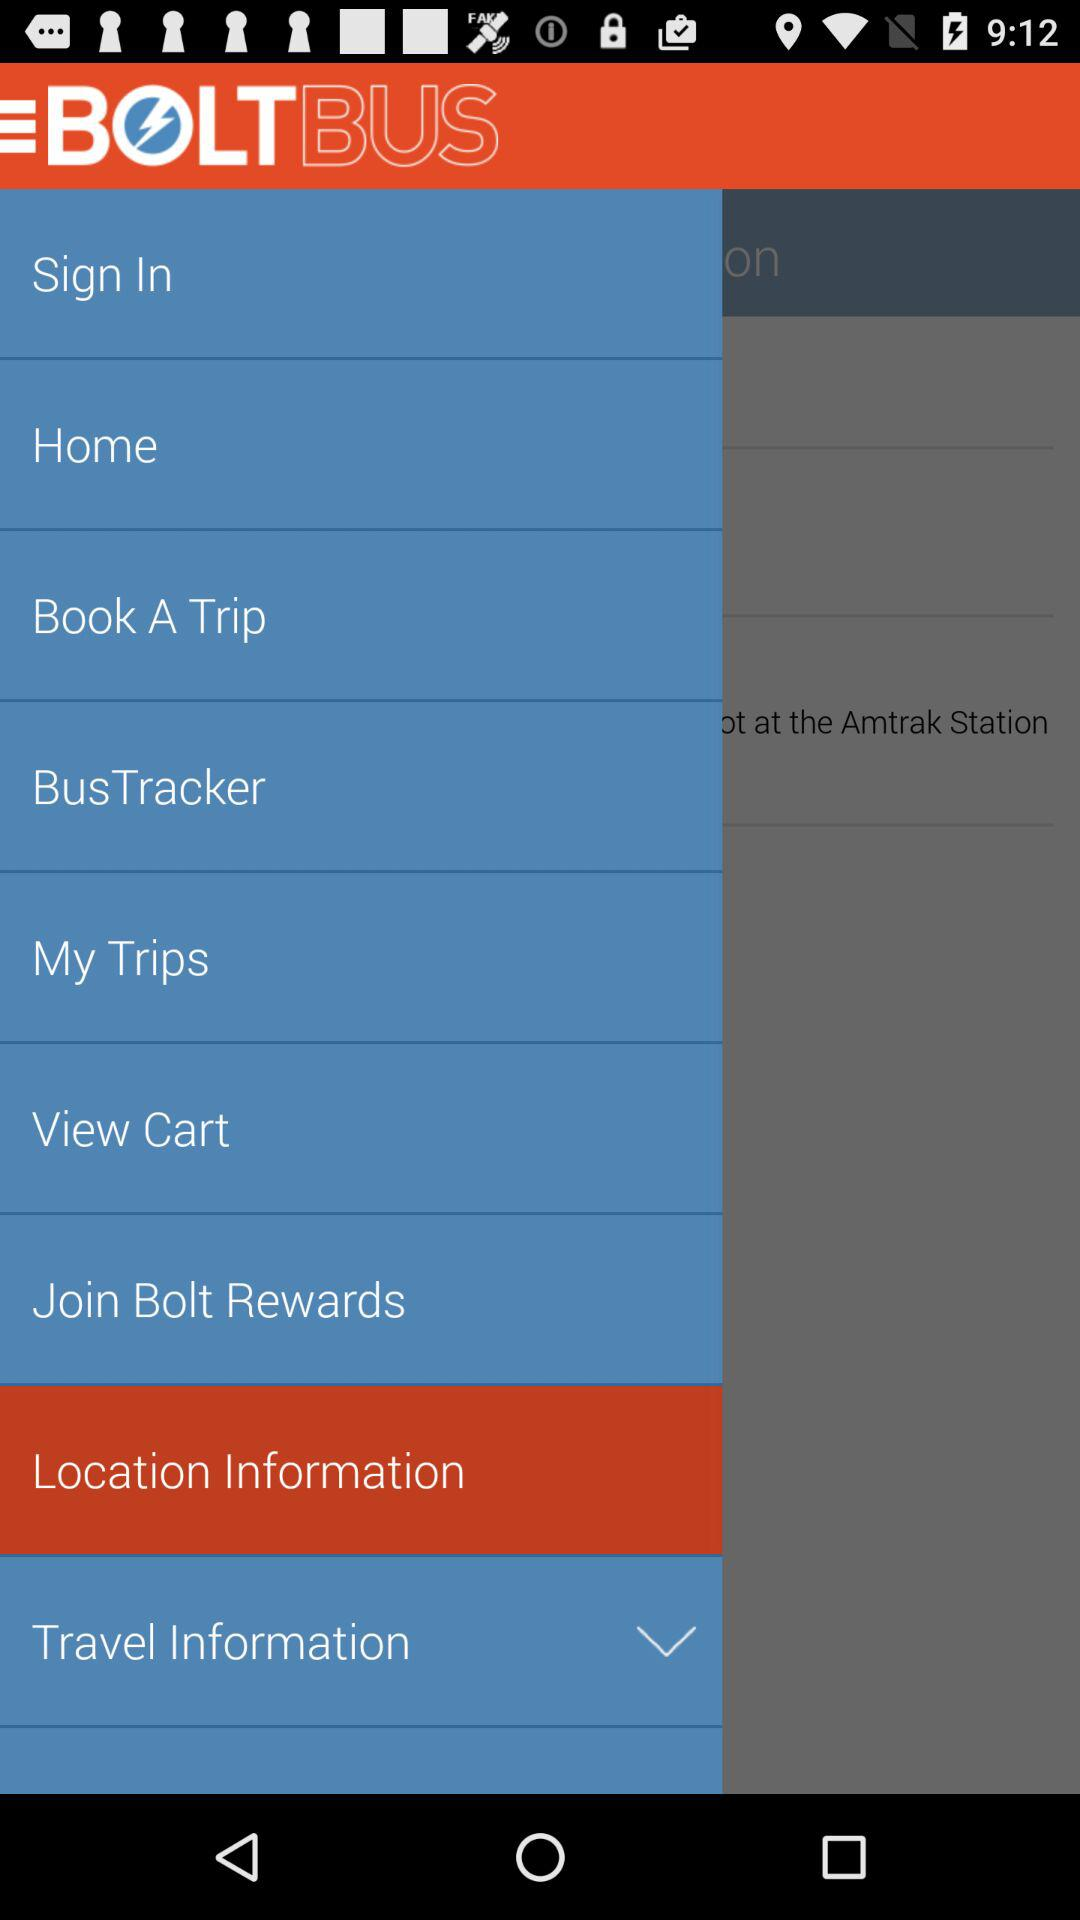What is the application name? The application name is "BOLTBUS". 